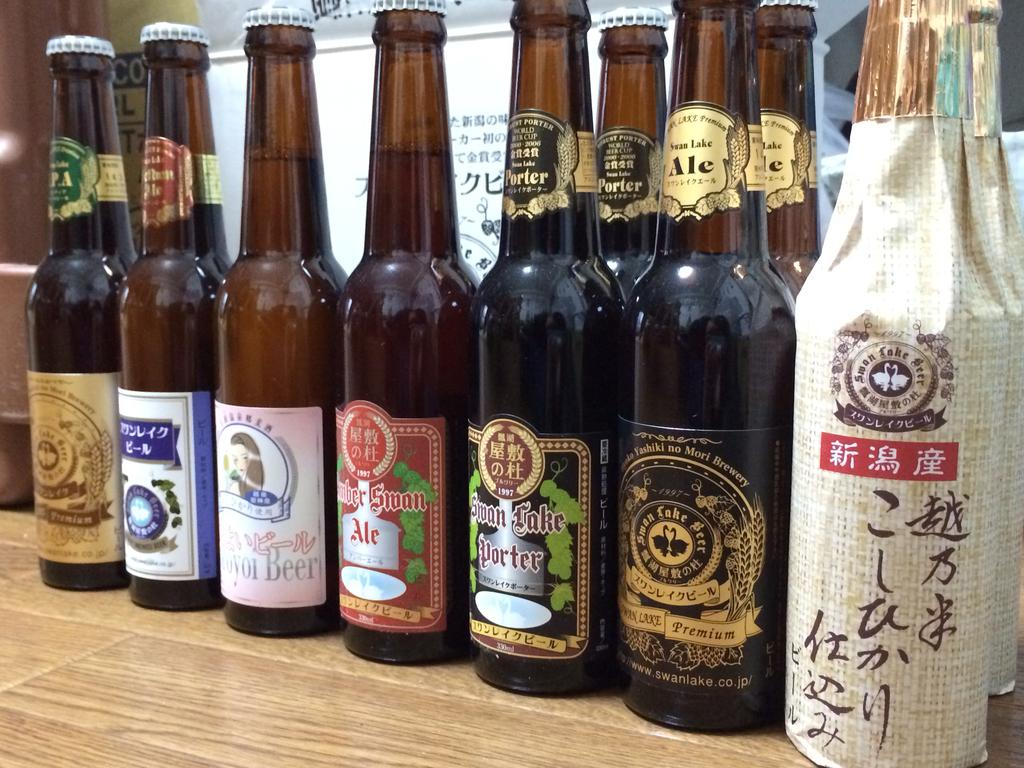Provide a one-sentence caption for the provided image. many beer bottles and one with the word swan on it. 